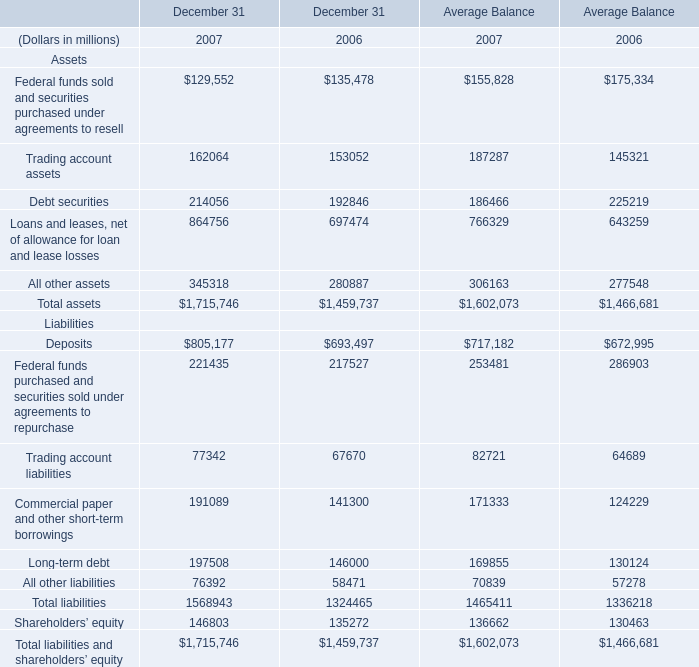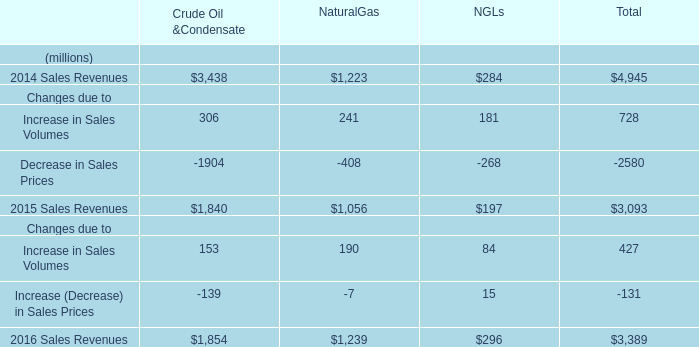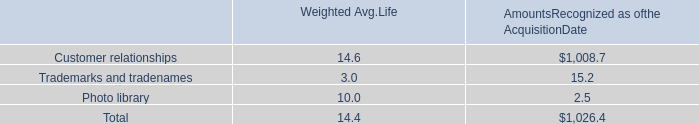What's the total amount of Trading account assets, Debt securities, All other assets and Loans and leases, net of allowance for loan and lease losses in 2006? (in million) 
Computations: (1466681 - 175334)
Answer: 1291347.0. 